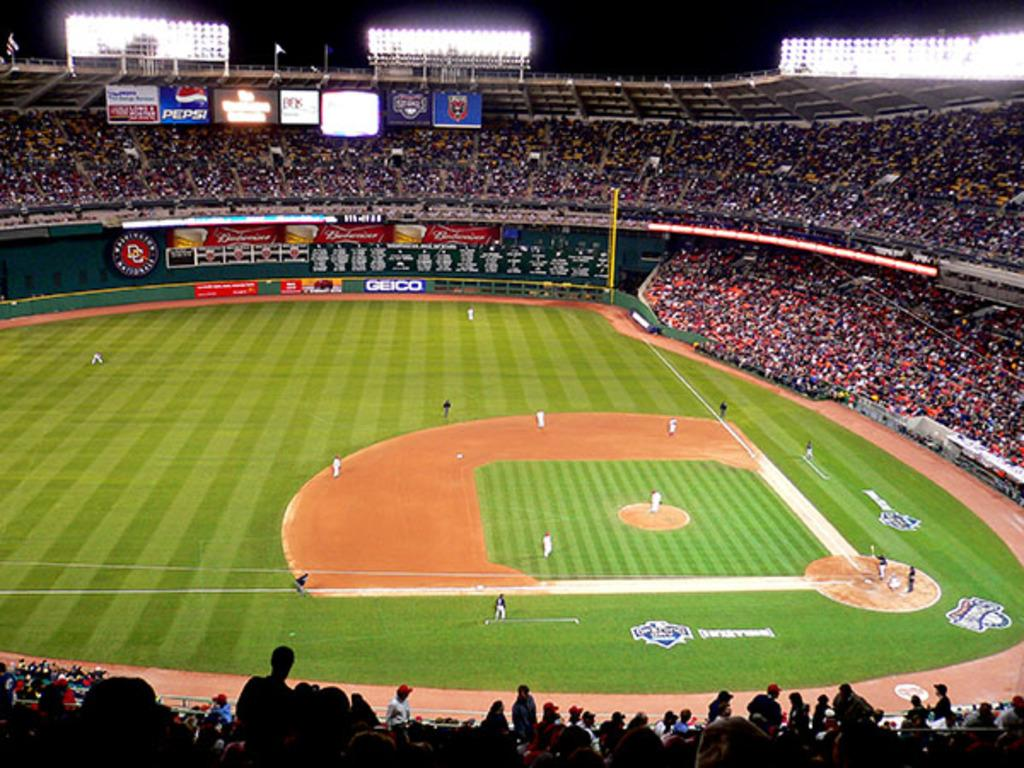What type of event is taking place in the image? The image depicts a baseball game stadium. What are the people on the ground doing? There are people playing baseball on the ground. What can be seen on the sides of the stadium? There are hoardings visible in the image. What is used to illuminate the stadium at night? Lights are present in the image. What can be seen flying in the air in the image? Flags are visible in the image. Who is watching the baseball game? There is an audience in the image. What other objects related to the baseball game can be seen in the image? Other objects related to the baseball game are present in the image. What type of cable is being used to connect the party to the net in the image? There is no party or net present in the image; it depicts a baseball game stadium. 